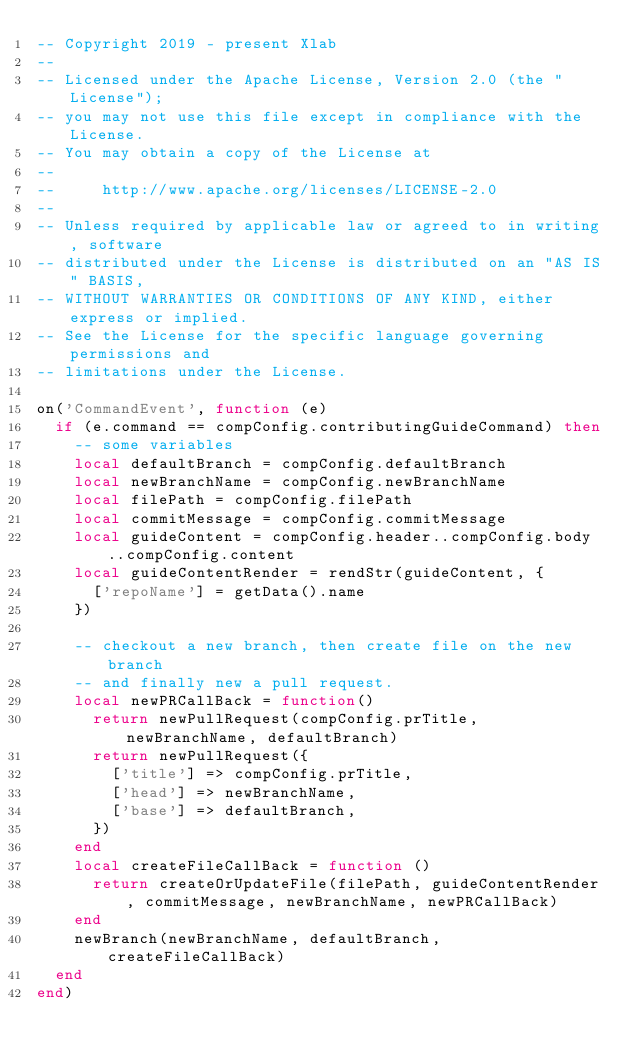<code> <loc_0><loc_0><loc_500><loc_500><_Lua_>-- Copyright 2019 - present Xlab
--
-- Licensed under the Apache License, Version 2.0 (the "License");
-- you may not use this file except in compliance with the License.
-- You may obtain a copy of the License at
--
--     http://www.apache.org/licenses/LICENSE-2.0
--
-- Unless required by applicable law or agreed to in writing, software
-- distributed under the License is distributed on an "AS IS" BASIS,
-- WITHOUT WARRANTIES OR CONDITIONS OF ANY KIND, either express or implied.
-- See the License for the specific language governing permissions and
-- limitations under the License.

on('CommandEvent', function (e)
  if (e.command == compConfig.contributingGuideCommand) then
    -- some variables
    local defaultBranch = compConfig.defaultBranch
    local newBranchName = compConfig.newBranchName
    local filePath = compConfig.filePath
    local commitMessage = compConfig.commitMessage
    local guideContent = compConfig.header..compConfig.body..compConfig.content
    local guideContentRender = rendStr(guideContent, {
      ['repoName'] = getData().name
    })

    -- checkout a new branch, then create file on the new branch
    -- and finally new a pull request.
    local newPRCallBack = function()
      return newPullRequest(compConfig.prTitle, newBranchName, defaultBranch)
      return newPullRequest({
        ['title'] => compConfig.prTitle,
        ['head'] => newBranchName,
        ['base'] => defaultBranch,
      })
    end
    local createFileCallBack = function ()
      return createOrUpdateFile(filePath, guideContentRender, commitMessage, newBranchName, newPRCallBack)
    end
    newBranch(newBranchName, defaultBranch, createFileCallBack)
  end
end)
</code> 